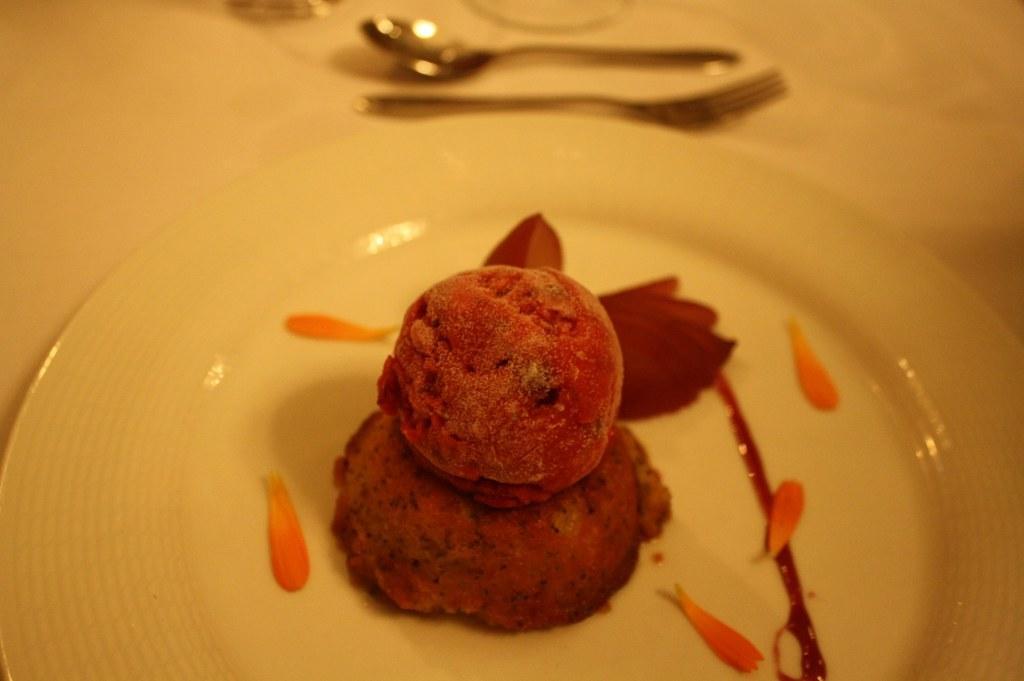How would you summarize this image in a sentence or two? In this image, I can see a food item on a plate. At the top of the image, I can see a spoon and a fork. I think this is a table. 